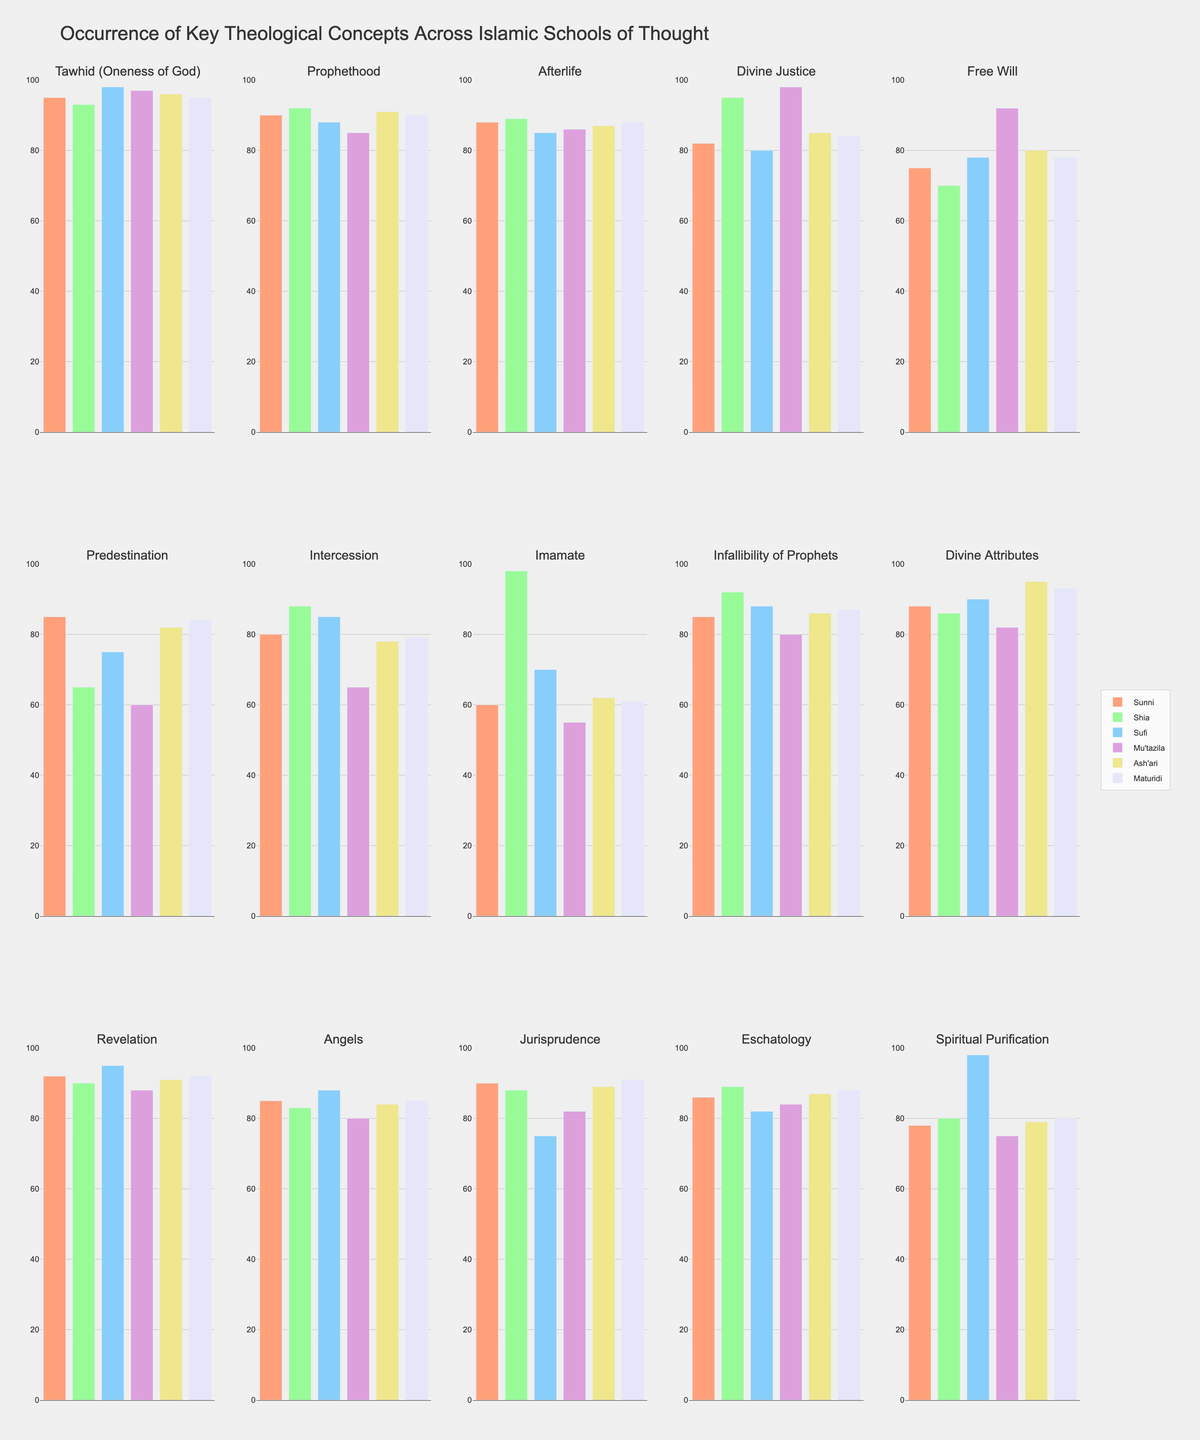Which Islamic school of thought has the highest occurrence of the concept "Divine Justice"? To determine the Islamic school of thought with the highest occurrence of the concept "Divine Justice", look at the bar heights for "Divine Justice". The Mu'tazila bar is the tallest, indicating it has the highest occurrence.
Answer: Mu'tazila Which concept has the smallest difference in occurrence between Sunni and Ash'ari? For each concept, calculate the absolute difference between Sunni and Ash'ari values. The smallest absolute difference is for "Tawhid (Oneness of God)", with a difference of 95 - 96 = 1.
Answer: Tawhid (Oneness of God) What is the average occurrence of the concept "Intercession" across all schools of thought? To find the average occurrence of "Intercession", sum up the values for all schools of thought and divide by the number of schools (6). The sum is 80+88+85+65+78+79 = 475, so the average is 475 / 6.
Answer: 79.17 Which school of thought has the lowest occurrence of the concept "Predestination" and what is the value? Examine all bar heights for "Predestination". The smallest bar is for Mu'tazila, with a value of 60.
Answer: Mu'tazila, 60 Compare the occurrence of the concept "Imamate" between Sunni and Shia. Look at the bars for "Imamate" for both Sunni and Shia. Sunni has a value of 60 and Shia has a value of 98.
Answer: Shia has a significantly higher occurrence (98 compared to 60) Which concept shows a unique high value for Sufi compared to other schools? Identify concepts where the Sufi bar is significantly higher than for other schools. "Spiritual Purification" has a notably higher value for Sufi (98) compared to others.
Answer: Spiritual Purification 